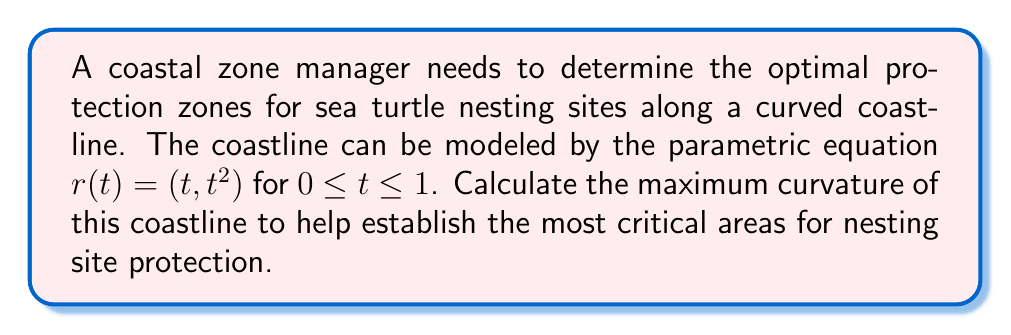Give your solution to this math problem. To find the maximum curvature of the coastline, we'll follow these steps:

1) The curvature κ of a parametric curve is given by:

   $$κ = \frac{|x'y'' - y'x''|}{(x'^2 + y'^2)^{3/2}}$$

2) For our curve $r(t) = (t, t^2)$, we have:
   $x(t) = t$, $y(t) = t^2$

3) Calculate the first derivatives:
   $x'(t) = 1$, $y'(t) = 2t$

4) Calculate the second derivatives:
   $x''(t) = 0$, $y''(t) = 2$

5) Substitute these into the curvature formula:

   $$κ(t) = \frac{|1 \cdot 2 - 2t \cdot 0|}{(1^2 + (2t)^2)^{3/2}}$$

6) Simplify:

   $$κ(t) = \frac{2}{(1 + 4t^2)^{3/2}}$$

7) To find the maximum curvature, we need to find the minimum value of the denominator, which occurs when $t = 0$.

8) Therefore, the maximum curvature is:

   $$κ_{max} = κ(0) = \frac{2}{(1 + 4 \cdot 0^2)^{3/2}} = 2$$

This maximum curvature occurs at the origin (0,0), indicating that this point on the coastline has the sharpest turn and may require the most intensive protection measures for sea turtle nesting sites.
Answer: $2$ 